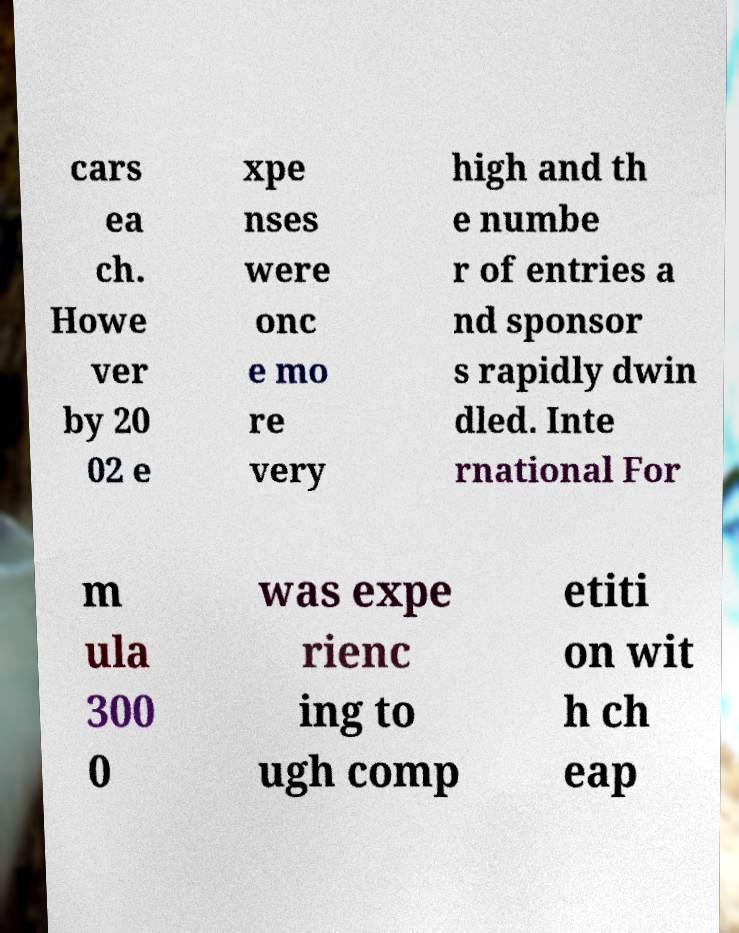Could you assist in decoding the text presented in this image and type it out clearly? cars ea ch. Howe ver by 20 02 e xpe nses were onc e mo re very high and th e numbe r of entries a nd sponsor s rapidly dwin dled. Inte rnational For m ula 300 0 was expe rienc ing to ugh comp etiti on wit h ch eap 